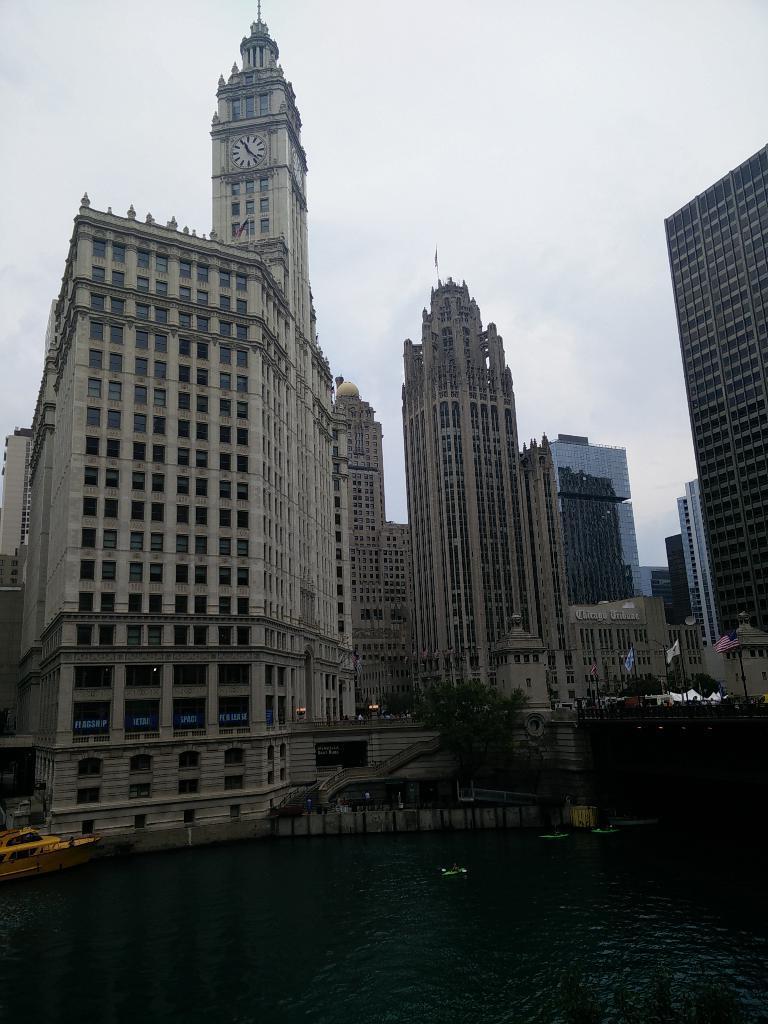How would you summarize this image in a sentence or two? In this image I can see there are few buildings, there are windows, a tower with clock and there is a lake, there is a boat on the water at left side and the sky is clear. 